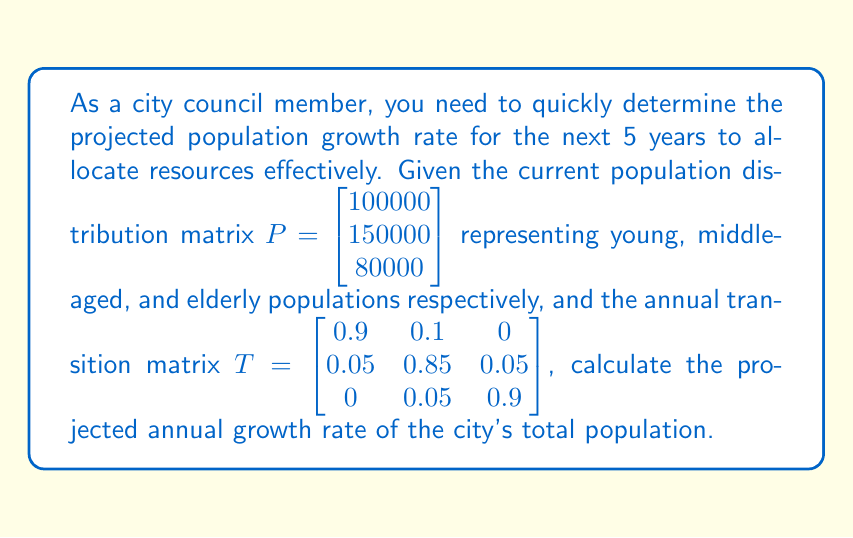Show me your answer to this math problem. To solve this problem, we'll follow these steps:

1) First, we need to calculate the population distribution after 5 years. This can be done by multiplying the transition matrix by itself 5 times and then multiplying the result by the initial population matrix.

   $$P_5 = T^5 \cdot P$$

2) Calculate $T^5$:
   $$T^5 = \begin{bmatrix} 0.6561 & 0.2916 & 0.0523 \\ 0.1458 & 0.6998 & 0.1544 \\ 0.0261 & 0.1746 & 0.7993 \end{bmatrix}$$

3) Now, multiply $T^5$ by $P$:
   $$P_5 = \begin{bmatrix} 0.6561 & 0.2916 & 0.0523 \\ 0.1458 & 0.6998 & 0.1544 \\ 0.0261 & 0.1746 & 0.7993 \end{bmatrix} \cdot \begin{bmatrix} 100000 \\ 150000 \\ 80000 \end{bmatrix}$$

   $$P_5 = \begin{bmatrix} 108315 \\ 143970 \\ 80715 \end{bmatrix}$$

4) Calculate the total population now and after 5 years:
   Initial total: 100000 + 150000 + 80000 = 330000
   After 5 years: 108315 + 143970 + 80715 = 333000

5) Calculate the total growth rate over 5 years:
   $$(333000 - 330000) / 330000 = 0.00909 = 0.909\%$$

6) Convert this to an annual growth rate:
   $$(1 + r)^5 = 1.00909$$
   $$r = (1.00909)^{1/5} - 1 = 0.00181 = 0.181\%$$

Thus, the projected annual growth rate is approximately 0.181%.
Answer: The projected annual growth rate of the city's total population is 0.181%. 